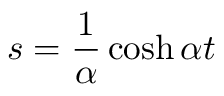<formula> <loc_0><loc_0><loc_500><loc_500>s = \frac { 1 } { \alpha } \cosh \alpha t</formula> 